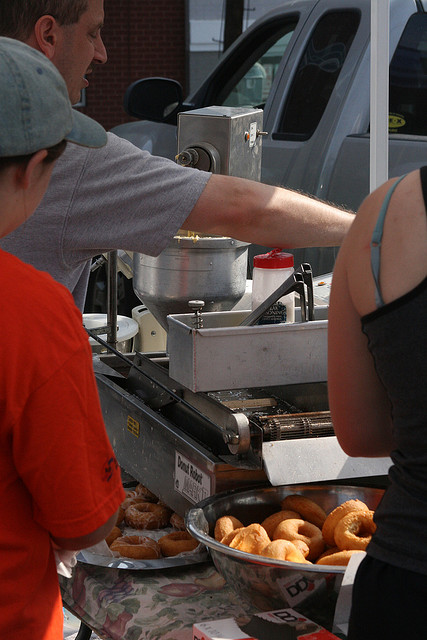Please identify all text content in this image. DD DD 